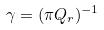<formula> <loc_0><loc_0><loc_500><loc_500>\gamma = ( \pi Q _ { r } ) ^ { - 1 }</formula> 